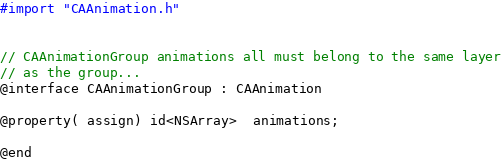Convert code to text. <code><loc_0><loc_0><loc_500><loc_500><_C_>#import "CAAnimation.h"


// CAAnimationGroup animations all must belong to the same layer
// as the group...
@interface CAAnimationGroup : CAAnimation

@property( assign) id<NSArray>  animations;

@end
</code> 